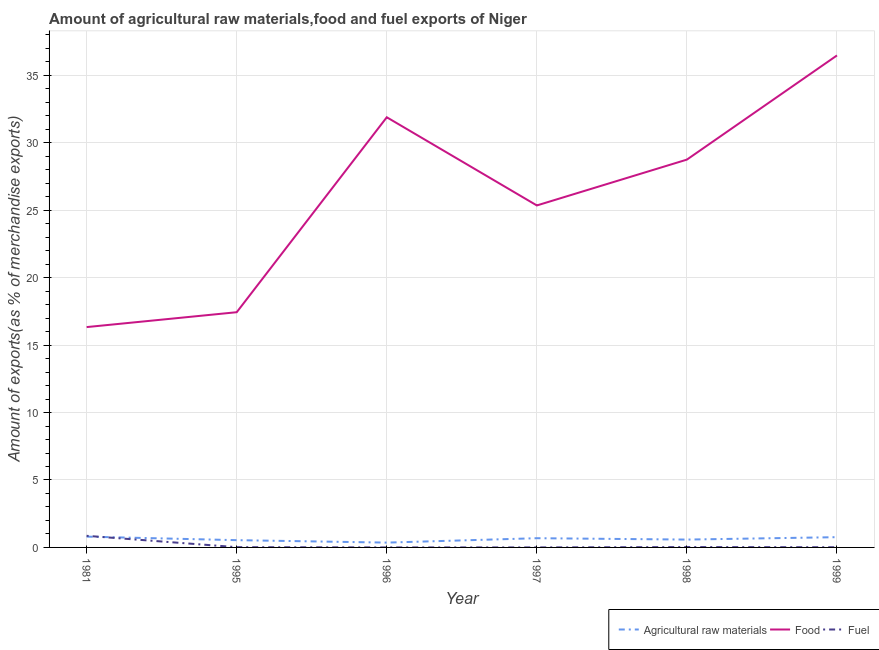How many different coloured lines are there?
Your answer should be compact. 3. What is the percentage of food exports in 1998?
Give a very brief answer. 28.76. Across all years, what is the maximum percentage of food exports?
Give a very brief answer. 36.48. Across all years, what is the minimum percentage of raw materials exports?
Offer a terse response. 0.36. In which year was the percentage of raw materials exports minimum?
Your answer should be very brief. 1996. What is the total percentage of food exports in the graph?
Your answer should be very brief. 156.27. What is the difference between the percentage of food exports in 1997 and that in 1999?
Provide a succinct answer. -11.12. What is the difference between the percentage of raw materials exports in 1981 and the percentage of fuel exports in 1997?
Provide a short and direct response. 0.8. What is the average percentage of fuel exports per year?
Provide a succinct answer. 0.15. In the year 1981, what is the difference between the percentage of fuel exports and percentage of food exports?
Provide a short and direct response. -15.48. In how many years, is the percentage of food exports greater than 22 %?
Make the answer very short. 4. What is the ratio of the percentage of fuel exports in 1995 to that in 1997?
Offer a terse response. 19.92. Is the difference between the percentage of food exports in 1997 and 1999 greater than the difference between the percentage of fuel exports in 1997 and 1999?
Provide a short and direct response. No. What is the difference between the highest and the second highest percentage of fuel exports?
Your answer should be compact. 0.83. What is the difference between the highest and the lowest percentage of fuel exports?
Provide a short and direct response. 0.86. Does the percentage of fuel exports monotonically increase over the years?
Keep it short and to the point. No. How many years are there in the graph?
Make the answer very short. 6. What is the difference between two consecutive major ticks on the Y-axis?
Give a very brief answer. 5. Are the values on the major ticks of Y-axis written in scientific E-notation?
Your answer should be very brief. No. Does the graph contain any zero values?
Ensure brevity in your answer.  No. How many legend labels are there?
Your answer should be compact. 3. What is the title of the graph?
Your response must be concise. Amount of agricultural raw materials,food and fuel exports of Niger. What is the label or title of the X-axis?
Provide a short and direct response. Year. What is the label or title of the Y-axis?
Provide a short and direct response. Amount of exports(as % of merchandise exports). What is the Amount of exports(as % of merchandise exports) in Agricultural raw materials in 1981?
Provide a short and direct response. 0.8. What is the Amount of exports(as % of merchandise exports) of Food in 1981?
Make the answer very short. 16.34. What is the Amount of exports(as % of merchandise exports) of Fuel in 1981?
Keep it short and to the point. 0.86. What is the Amount of exports(as % of merchandise exports) in Agricultural raw materials in 1995?
Ensure brevity in your answer.  0.54. What is the Amount of exports(as % of merchandise exports) of Food in 1995?
Provide a succinct answer. 17.44. What is the Amount of exports(as % of merchandise exports) in Fuel in 1995?
Your response must be concise. 0.02. What is the Amount of exports(as % of merchandise exports) of Agricultural raw materials in 1996?
Provide a succinct answer. 0.36. What is the Amount of exports(as % of merchandise exports) in Food in 1996?
Provide a short and direct response. 31.9. What is the Amount of exports(as % of merchandise exports) of Fuel in 1996?
Ensure brevity in your answer.  0. What is the Amount of exports(as % of merchandise exports) of Agricultural raw materials in 1997?
Make the answer very short. 0.68. What is the Amount of exports(as % of merchandise exports) in Food in 1997?
Your answer should be compact. 25.36. What is the Amount of exports(as % of merchandise exports) in Fuel in 1997?
Keep it short and to the point. 0. What is the Amount of exports(as % of merchandise exports) of Agricultural raw materials in 1998?
Make the answer very short. 0.58. What is the Amount of exports(as % of merchandise exports) in Food in 1998?
Offer a very short reply. 28.76. What is the Amount of exports(as % of merchandise exports) of Fuel in 1998?
Your response must be concise. 0.03. What is the Amount of exports(as % of merchandise exports) in Agricultural raw materials in 1999?
Offer a very short reply. 0.76. What is the Amount of exports(as % of merchandise exports) in Food in 1999?
Provide a short and direct response. 36.48. What is the Amount of exports(as % of merchandise exports) of Fuel in 1999?
Keep it short and to the point. 0.01. Across all years, what is the maximum Amount of exports(as % of merchandise exports) in Agricultural raw materials?
Make the answer very short. 0.8. Across all years, what is the maximum Amount of exports(as % of merchandise exports) of Food?
Your response must be concise. 36.48. Across all years, what is the maximum Amount of exports(as % of merchandise exports) of Fuel?
Provide a short and direct response. 0.86. Across all years, what is the minimum Amount of exports(as % of merchandise exports) in Agricultural raw materials?
Your answer should be very brief. 0.36. Across all years, what is the minimum Amount of exports(as % of merchandise exports) of Food?
Keep it short and to the point. 16.34. Across all years, what is the minimum Amount of exports(as % of merchandise exports) in Fuel?
Offer a terse response. 0. What is the total Amount of exports(as % of merchandise exports) in Agricultural raw materials in the graph?
Keep it short and to the point. 3.72. What is the total Amount of exports(as % of merchandise exports) in Food in the graph?
Ensure brevity in your answer.  156.27. What is the total Amount of exports(as % of merchandise exports) in Fuel in the graph?
Offer a terse response. 0.92. What is the difference between the Amount of exports(as % of merchandise exports) in Agricultural raw materials in 1981 and that in 1995?
Make the answer very short. 0.26. What is the difference between the Amount of exports(as % of merchandise exports) in Food in 1981 and that in 1995?
Your response must be concise. -1.1. What is the difference between the Amount of exports(as % of merchandise exports) of Fuel in 1981 and that in 1995?
Make the answer very short. 0.84. What is the difference between the Amount of exports(as % of merchandise exports) in Agricultural raw materials in 1981 and that in 1996?
Ensure brevity in your answer.  0.44. What is the difference between the Amount of exports(as % of merchandise exports) of Food in 1981 and that in 1996?
Provide a succinct answer. -15.56. What is the difference between the Amount of exports(as % of merchandise exports) of Fuel in 1981 and that in 1996?
Offer a terse response. 0.86. What is the difference between the Amount of exports(as % of merchandise exports) of Agricultural raw materials in 1981 and that in 1997?
Give a very brief answer. 0.12. What is the difference between the Amount of exports(as % of merchandise exports) in Food in 1981 and that in 1997?
Your answer should be very brief. -9.02. What is the difference between the Amount of exports(as % of merchandise exports) in Fuel in 1981 and that in 1997?
Offer a terse response. 0.86. What is the difference between the Amount of exports(as % of merchandise exports) of Agricultural raw materials in 1981 and that in 1998?
Make the answer very short. 0.22. What is the difference between the Amount of exports(as % of merchandise exports) of Food in 1981 and that in 1998?
Keep it short and to the point. -12.42. What is the difference between the Amount of exports(as % of merchandise exports) in Fuel in 1981 and that in 1998?
Ensure brevity in your answer.  0.83. What is the difference between the Amount of exports(as % of merchandise exports) in Agricultural raw materials in 1981 and that in 1999?
Ensure brevity in your answer.  0.04. What is the difference between the Amount of exports(as % of merchandise exports) of Food in 1981 and that in 1999?
Your answer should be very brief. -20.14. What is the difference between the Amount of exports(as % of merchandise exports) in Fuel in 1981 and that in 1999?
Make the answer very short. 0.85. What is the difference between the Amount of exports(as % of merchandise exports) of Agricultural raw materials in 1995 and that in 1996?
Provide a succinct answer. 0.18. What is the difference between the Amount of exports(as % of merchandise exports) in Food in 1995 and that in 1996?
Give a very brief answer. -14.46. What is the difference between the Amount of exports(as % of merchandise exports) of Fuel in 1995 and that in 1996?
Offer a terse response. 0.02. What is the difference between the Amount of exports(as % of merchandise exports) of Agricultural raw materials in 1995 and that in 1997?
Ensure brevity in your answer.  -0.14. What is the difference between the Amount of exports(as % of merchandise exports) in Food in 1995 and that in 1997?
Ensure brevity in your answer.  -7.92. What is the difference between the Amount of exports(as % of merchandise exports) of Fuel in 1995 and that in 1997?
Your response must be concise. 0.02. What is the difference between the Amount of exports(as % of merchandise exports) in Agricultural raw materials in 1995 and that in 1998?
Your response must be concise. -0.04. What is the difference between the Amount of exports(as % of merchandise exports) in Food in 1995 and that in 1998?
Your response must be concise. -11.32. What is the difference between the Amount of exports(as % of merchandise exports) of Fuel in 1995 and that in 1998?
Make the answer very short. -0.01. What is the difference between the Amount of exports(as % of merchandise exports) in Agricultural raw materials in 1995 and that in 1999?
Ensure brevity in your answer.  -0.22. What is the difference between the Amount of exports(as % of merchandise exports) in Food in 1995 and that in 1999?
Provide a short and direct response. -19.04. What is the difference between the Amount of exports(as % of merchandise exports) of Fuel in 1995 and that in 1999?
Provide a succinct answer. 0. What is the difference between the Amount of exports(as % of merchandise exports) in Agricultural raw materials in 1996 and that in 1997?
Make the answer very short. -0.33. What is the difference between the Amount of exports(as % of merchandise exports) of Food in 1996 and that in 1997?
Give a very brief answer. 6.54. What is the difference between the Amount of exports(as % of merchandise exports) of Fuel in 1996 and that in 1997?
Your answer should be very brief. -0. What is the difference between the Amount of exports(as % of merchandise exports) in Agricultural raw materials in 1996 and that in 1998?
Make the answer very short. -0.22. What is the difference between the Amount of exports(as % of merchandise exports) of Food in 1996 and that in 1998?
Offer a terse response. 3.14. What is the difference between the Amount of exports(as % of merchandise exports) of Fuel in 1996 and that in 1998?
Make the answer very short. -0.03. What is the difference between the Amount of exports(as % of merchandise exports) in Agricultural raw materials in 1996 and that in 1999?
Your response must be concise. -0.4. What is the difference between the Amount of exports(as % of merchandise exports) in Food in 1996 and that in 1999?
Keep it short and to the point. -4.59. What is the difference between the Amount of exports(as % of merchandise exports) of Fuel in 1996 and that in 1999?
Keep it short and to the point. -0.01. What is the difference between the Amount of exports(as % of merchandise exports) in Agricultural raw materials in 1997 and that in 1998?
Your answer should be compact. 0.1. What is the difference between the Amount of exports(as % of merchandise exports) in Food in 1997 and that in 1998?
Your response must be concise. -3.4. What is the difference between the Amount of exports(as % of merchandise exports) in Fuel in 1997 and that in 1998?
Give a very brief answer. -0.03. What is the difference between the Amount of exports(as % of merchandise exports) in Agricultural raw materials in 1997 and that in 1999?
Offer a terse response. -0.08. What is the difference between the Amount of exports(as % of merchandise exports) in Food in 1997 and that in 1999?
Make the answer very short. -11.12. What is the difference between the Amount of exports(as % of merchandise exports) of Fuel in 1997 and that in 1999?
Offer a very short reply. -0.01. What is the difference between the Amount of exports(as % of merchandise exports) in Agricultural raw materials in 1998 and that in 1999?
Make the answer very short. -0.18. What is the difference between the Amount of exports(as % of merchandise exports) in Food in 1998 and that in 1999?
Offer a very short reply. -7.72. What is the difference between the Amount of exports(as % of merchandise exports) of Fuel in 1998 and that in 1999?
Provide a succinct answer. 0.01. What is the difference between the Amount of exports(as % of merchandise exports) in Agricultural raw materials in 1981 and the Amount of exports(as % of merchandise exports) in Food in 1995?
Provide a short and direct response. -16.64. What is the difference between the Amount of exports(as % of merchandise exports) in Agricultural raw materials in 1981 and the Amount of exports(as % of merchandise exports) in Fuel in 1995?
Keep it short and to the point. 0.78. What is the difference between the Amount of exports(as % of merchandise exports) in Food in 1981 and the Amount of exports(as % of merchandise exports) in Fuel in 1995?
Give a very brief answer. 16.32. What is the difference between the Amount of exports(as % of merchandise exports) of Agricultural raw materials in 1981 and the Amount of exports(as % of merchandise exports) of Food in 1996?
Your response must be concise. -31.1. What is the difference between the Amount of exports(as % of merchandise exports) in Agricultural raw materials in 1981 and the Amount of exports(as % of merchandise exports) in Fuel in 1996?
Offer a terse response. 0.8. What is the difference between the Amount of exports(as % of merchandise exports) in Food in 1981 and the Amount of exports(as % of merchandise exports) in Fuel in 1996?
Provide a succinct answer. 16.34. What is the difference between the Amount of exports(as % of merchandise exports) of Agricultural raw materials in 1981 and the Amount of exports(as % of merchandise exports) of Food in 1997?
Your answer should be compact. -24.56. What is the difference between the Amount of exports(as % of merchandise exports) of Agricultural raw materials in 1981 and the Amount of exports(as % of merchandise exports) of Fuel in 1997?
Give a very brief answer. 0.8. What is the difference between the Amount of exports(as % of merchandise exports) in Food in 1981 and the Amount of exports(as % of merchandise exports) in Fuel in 1997?
Ensure brevity in your answer.  16.34. What is the difference between the Amount of exports(as % of merchandise exports) of Agricultural raw materials in 1981 and the Amount of exports(as % of merchandise exports) of Food in 1998?
Ensure brevity in your answer.  -27.96. What is the difference between the Amount of exports(as % of merchandise exports) of Agricultural raw materials in 1981 and the Amount of exports(as % of merchandise exports) of Fuel in 1998?
Offer a very short reply. 0.77. What is the difference between the Amount of exports(as % of merchandise exports) in Food in 1981 and the Amount of exports(as % of merchandise exports) in Fuel in 1998?
Your response must be concise. 16.31. What is the difference between the Amount of exports(as % of merchandise exports) of Agricultural raw materials in 1981 and the Amount of exports(as % of merchandise exports) of Food in 1999?
Your answer should be very brief. -35.68. What is the difference between the Amount of exports(as % of merchandise exports) of Agricultural raw materials in 1981 and the Amount of exports(as % of merchandise exports) of Fuel in 1999?
Make the answer very short. 0.79. What is the difference between the Amount of exports(as % of merchandise exports) in Food in 1981 and the Amount of exports(as % of merchandise exports) in Fuel in 1999?
Keep it short and to the point. 16.32. What is the difference between the Amount of exports(as % of merchandise exports) in Agricultural raw materials in 1995 and the Amount of exports(as % of merchandise exports) in Food in 1996?
Provide a short and direct response. -31.36. What is the difference between the Amount of exports(as % of merchandise exports) of Agricultural raw materials in 1995 and the Amount of exports(as % of merchandise exports) of Fuel in 1996?
Provide a succinct answer. 0.54. What is the difference between the Amount of exports(as % of merchandise exports) of Food in 1995 and the Amount of exports(as % of merchandise exports) of Fuel in 1996?
Give a very brief answer. 17.44. What is the difference between the Amount of exports(as % of merchandise exports) in Agricultural raw materials in 1995 and the Amount of exports(as % of merchandise exports) in Food in 1997?
Your answer should be very brief. -24.82. What is the difference between the Amount of exports(as % of merchandise exports) of Agricultural raw materials in 1995 and the Amount of exports(as % of merchandise exports) of Fuel in 1997?
Offer a very short reply. 0.54. What is the difference between the Amount of exports(as % of merchandise exports) in Food in 1995 and the Amount of exports(as % of merchandise exports) in Fuel in 1997?
Make the answer very short. 17.44. What is the difference between the Amount of exports(as % of merchandise exports) of Agricultural raw materials in 1995 and the Amount of exports(as % of merchandise exports) of Food in 1998?
Offer a terse response. -28.22. What is the difference between the Amount of exports(as % of merchandise exports) of Agricultural raw materials in 1995 and the Amount of exports(as % of merchandise exports) of Fuel in 1998?
Give a very brief answer. 0.51. What is the difference between the Amount of exports(as % of merchandise exports) of Food in 1995 and the Amount of exports(as % of merchandise exports) of Fuel in 1998?
Offer a terse response. 17.41. What is the difference between the Amount of exports(as % of merchandise exports) of Agricultural raw materials in 1995 and the Amount of exports(as % of merchandise exports) of Food in 1999?
Your answer should be compact. -35.94. What is the difference between the Amount of exports(as % of merchandise exports) of Agricultural raw materials in 1995 and the Amount of exports(as % of merchandise exports) of Fuel in 1999?
Give a very brief answer. 0.52. What is the difference between the Amount of exports(as % of merchandise exports) in Food in 1995 and the Amount of exports(as % of merchandise exports) in Fuel in 1999?
Make the answer very short. 17.43. What is the difference between the Amount of exports(as % of merchandise exports) in Agricultural raw materials in 1996 and the Amount of exports(as % of merchandise exports) in Food in 1997?
Make the answer very short. -25. What is the difference between the Amount of exports(as % of merchandise exports) in Agricultural raw materials in 1996 and the Amount of exports(as % of merchandise exports) in Fuel in 1997?
Ensure brevity in your answer.  0.36. What is the difference between the Amount of exports(as % of merchandise exports) of Food in 1996 and the Amount of exports(as % of merchandise exports) of Fuel in 1997?
Your answer should be very brief. 31.89. What is the difference between the Amount of exports(as % of merchandise exports) of Agricultural raw materials in 1996 and the Amount of exports(as % of merchandise exports) of Food in 1998?
Make the answer very short. -28.4. What is the difference between the Amount of exports(as % of merchandise exports) of Agricultural raw materials in 1996 and the Amount of exports(as % of merchandise exports) of Fuel in 1998?
Your response must be concise. 0.33. What is the difference between the Amount of exports(as % of merchandise exports) in Food in 1996 and the Amount of exports(as % of merchandise exports) in Fuel in 1998?
Provide a succinct answer. 31.87. What is the difference between the Amount of exports(as % of merchandise exports) in Agricultural raw materials in 1996 and the Amount of exports(as % of merchandise exports) in Food in 1999?
Offer a terse response. -36.12. What is the difference between the Amount of exports(as % of merchandise exports) in Agricultural raw materials in 1996 and the Amount of exports(as % of merchandise exports) in Fuel in 1999?
Offer a very short reply. 0.34. What is the difference between the Amount of exports(as % of merchandise exports) of Food in 1996 and the Amount of exports(as % of merchandise exports) of Fuel in 1999?
Make the answer very short. 31.88. What is the difference between the Amount of exports(as % of merchandise exports) in Agricultural raw materials in 1997 and the Amount of exports(as % of merchandise exports) in Food in 1998?
Provide a succinct answer. -28.07. What is the difference between the Amount of exports(as % of merchandise exports) in Agricultural raw materials in 1997 and the Amount of exports(as % of merchandise exports) in Fuel in 1998?
Provide a short and direct response. 0.66. What is the difference between the Amount of exports(as % of merchandise exports) of Food in 1997 and the Amount of exports(as % of merchandise exports) of Fuel in 1998?
Keep it short and to the point. 25.33. What is the difference between the Amount of exports(as % of merchandise exports) in Agricultural raw materials in 1997 and the Amount of exports(as % of merchandise exports) in Food in 1999?
Give a very brief answer. -35.8. What is the difference between the Amount of exports(as % of merchandise exports) of Agricultural raw materials in 1997 and the Amount of exports(as % of merchandise exports) of Fuel in 1999?
Offer a very short reply. 0.67. What is the difference between the Amount of exports(as % of merchandise exports) of Food in 1997 and the Amount of exports(as % of merchandise exports) of Fuel in 1999?
Offer a terse response. 25.34. What is the difference between the Amount of exports(as % of merchandise exports) of Agricultural raw materials in 1998 and the Amount of exports(as % of merchandise exports) of Food in 1999?
Provide a succinct answer. -35.9. What is the difference between the Amount of exports(as % of merchandise exports) in Agricultural raw materials in 1998 and the Amount of exports(as % of merchandise exports) in Fuel in 1999?
Keep it short and to the point. 0.57. What is the difference between the Amount of exports(as % of merchandise exports) in Food in 1998 and the Amount of exports(as % of merchandise exports) in Fuel in 1999?
Provide a short and direct response. 28.74. What is the average Amount of exports(as % of merchandise exports) in Agricultural raw materials per year?
Offer a terse response. 0.62. What is the average Amount of exports(as % of merchandise exports) of Food per year?
Your answer should be compact. 26.05. What is the average Amount of exports(as % of merchandise exports) in Fuel per year?
Your answer should be compact. 0.15. In the year 1981, what is the difference between the Amount of exports(as % of merchandise exports) of Agricultural raw materials and Amount of exports(as % of merchandise exports) of Food?
Ensure brevity in your answer.  -15.54. In the year 1981, what is the difference between the Amount of exports(as % of merchandise exports) of Agricultural raw materials and Amount of exports(as % of merchandise exports) of Fuel?
Offer a very short reply. -0.06. In the year 1981, what is the difference between the Amount of exports(as % of merchandise exports) of Food and Amount of exports(as % of merchandise exports) of Fuel?
Offer a very short reply. 15.48. In the year 1995, what is the difference between the Amount of exports(as % of merchandise exports) of Agricultural raw materials and Amount of exports(as % of merchandise exports) of Food?
Your answer should be compact. -16.9. In the year 1995, what is the difference between the Amount of exports(as % of merchandise exports) in Agricultural raw materials and Amount of exports(as % of merchandise exports) in Fuel?
Your answer should be compact. 0.52. In the year 1995, what is the difference between the Amount of exports(as % of merchandise exports) of Food and Amount of exports(as % of merchandise exports) of Fuel?
Offer a very short reply. 17.42. In the year 1996, what is the difference between the Amount of exports(as % of merchandise exports) in Agricultural raw materials and Amount of exports(as % of merchandise exports) in Food?
Offer a terse response. -31.54. In the year 1996, what is the difference between the Amount of exports(as % of merchandise exports) of Agricultural raw materials and Amount of exports(as % of merchandise exports) of Fuel?
Provide a succinct answer. 0.36. In the year 1996, what is the difference between the Amount of exports(as % of merchandise exports) of Food and Amount of exports(as % of merchandise exports) of Fuel?
Offer a very short reply. 31.9. In the year 1997, what is the difference between the Amount of exports(as % of merchandise exports) in Agricultural raw materials and Amount of exports(as % of merchandise exports) in Food?
Your answer should be very brief. -24.67. In the year 1997, what is the difference between the Amount of exports(as % of merchandise exports) in Agricultural raw materials and Amount of exports(as % of merchandise exports) in Fuel?
Make the answer very short. 0.68. In the year 1997, what is the difference between the Amount of exports(as % of merchandise exports) of Food and Amount of exports(as % of merchandise exports) of Fuel?
Your answer should be very brief. 25.36. In the year 1998, what is the difference between the Amount of exports(as % of merchandise exports) of Agricultural raw materials and Amount of exports(as % of merchandise exports) of Food?
Provide a succinct answer. -28.17. In the year 1998, what is the difference between the Amount of exports(as % of merchandise exports) of Agricultural raw materials and Amount of exports(as % of merchandise exports) of Fuel?
Your answer should be compact. 0.56. In the year 1998, what is the difference between the Amount of exports(as % of merchandise exports) in Food and Amount of exports(as % of merchandise exports) in Fuel?
Make the answer very short. 28.73. In the year 1999, what is the difference between the Amount of exports(as % of merchandise exports) in Agricultural raw materials and Amount of exports(as % of merchandise exports) in Food?
Ensure brevity in your answer.  -35.72. In the year 1999, what is the difference between the Amount of exports(as % of merchandise exports) of Agricultural raw materials and Amount of exports(as % of merchandise exports) of Fuel?
Provide a succinct answer. 0.75. In the year 1999, what is the difference between the Amount of exports(as % of merchandise exports) of Food and Amount of exports(as % of merchandise exports) of Fuel?
Your answer should be very brief. 36.47. What is the ratio of the Amount of exports(as % of merchandise exports) of Agricultural raw materials in 1981 to that in 1995?
Provide a short and direct response. 1.48. What is the ratio of the Amount of exports(as % of merchandise exports) of Food in 1981 to that in 1995?
Provide a short and direct response. 0.94. What is the ratio of the Amount of exports(as % of merchandise exports) in Fuel in 1981 to that in 1995?
Provide a succinct answer. 44.45. What is the ratio of the Amount of exports(as % of merchandise exports) in Agricultural raw materials in 1981 to that in 1996?
Give a very brief answer. 2.24. What is the ratio of the Amount of exports(as % of merchandise exports) in Food in 1981 to that in 1996?
Your response must be concise. 0.51. What is the ratio of the Amount of exports(as % of merchandise exports) of Fuel in 1981 to that in 1996?
Your response must be concise. 5528.42. What is the ratio of the Amount of exports(as % of merchandise exports) of Agricultural raw materials in 1981 to that in 1997?
Offer a very short reply. 1.17. What is the ratio of the Amount of exports(as % of merchandise exports) of Food in 1981 to that in 1997?
Make the answer very short. 0.64. What is the ratio of the Amount of exports(as % of merchandise exports) of Fuel in 1981 to that in 1997?
Ensure brevity in your answer.  885.19. What is the ratio of the Amount of exports(as % of merchandise exports) of Agricultural raw materials in 1981 to that in 1998?
Make the answer very short. 1.38. What is the ratio of the Amount of exports(as % of merchandise exports) of Food in 1981 to that in 1998?
Your response must be concise. 0.57. What is the ratio of the Amount of exports(as % of merchandise exports) of Fuel in 1981 to that in 1998?
Provide a succinct answer. 32.17. What is the ratio of the Amount of exports(as % of merchandise exports) in Agricultural raw materials in 1981 to that in 1999?
Offer a terse response. 1.05. What is the ratio of the Amount of exports(as % of merchandise exports) of Food in 1981 to that in 1999?
Offer a terse response. 0.45. What is the ratio of the Amount of exports(as % of merchandise exports) of Fuel in 1981 to that in 1999?
Keep it short and to the point. 59.36. What is the ratio of the Amount of exports(as % of merchandise exports) of Agricultural raw materials in 1995 to that in 1996?
Provide a short and direct response. 1.51. What is the ratio of the Amount of exports(as % of merchandise exports) in Food in 1995 to that in 1996?
Make the answer very short. 0.55. What is the ratio of the Amount of exports(as % of merchandise exports) of Fuel in 1995 to that in 1996?
Provide a short and direct response. 124.39. What is the ratio of the Amount of exports(as % of merchandise exports) of Agricultural raw materials in 1995 to that in 1997?
Offer a very short reply. 0.79. What is the ratio of the Amount of exports(as % of merchandise exports) in Food in 1995 to that in 1997?
Keep it short and to the point. 0.69. What is the ratio of the Amount of exports(as % of merchandise exports) of Fuel in 1995 to that in 1997?
Provide a succinct answer. 19.92. What is the ratio of the Amount of exports(as % of merchandise exports) in Agricultural raw materials in 1995 to that in 1998?
Your response must be concise. 0.93. What is the ratio of the Amount of exports(as % of merchandise exports) in Food in 1995 to that in 1998?
Give a very brief answer. 0.61. What is the ratio of the Amount of exports(as % of merchandise exports) in Fuel in 1995 to that in 1998?
Your answer should be very brief. 0.72. What is the ratio of the Amount of exports(as % of merchandise exports) of Agricultural raw materials in 1995 to that in 1999?
Provide a succinct answer. 0.71. What is the ratio of the Amount of exports(as % of merchandise exports) in Food in 1995 to that in 1999?
Provide a succinct answer. 0.48. What is the ratio of the Amount of exports(as % of merchandise exports) in Fuel in 1995 to that in 1999?
Offer a very short reply. 1.34. What is the ratio of the Amount of exports(as % of merchandise exports) of Agricultural raw materials in 1996 to that in 1997?
Provide a short and direct response. 0.52. What is the ratio of the Amount of exports(as % of merchandise exports) in Food in 1996 to that in 1997?
Offer a very short reply. 1.26. What is the ratio of the Amount of exports(as % of merchandise exports) of Fuel in 1996 to that in 1997?
Ensure brevity in your answer.  0.16. What is the ratio of the Amount of exports(as % of merchandise exports) in Agricultural raw materials in 1996 to that in 1998?
Offer a terse response. 0.61. What is the ratio of the Amount of exports(as % of merchandise exports) of Food in 1996 to that in 1998?
Provide a short and direct response. 1.11. What is the ratio of the Amount of exports(as % of merchandise exports) of Fuel in 1996 to that in 1998?
Give a very brief answer. 0.01. What is the ratio of the Amount of exports(as % of merchandise exports) in Agricultural raw materials in 1996 to that in 1999?
Your answer should be compact. 0.47. What is the ratio of the Amount of exports(as % of merchandise exports) in Food in 1996 to that in 1999?
Keep it short and to the point. 0.87. What is the ratio of the Amount of exports(as % of merchandise exports) in Fuel in 1996 to that in 1999?
Ensure brevity in your answer.  0.01. What is the ratio of the Amount of exports(as % of merchandise exports) in Agricultural raw materials in 1997 to that in 1998?
Provide a succinct answer. 1.18. What is the ratio of the Amount of exports(as % of merchandise exports) in Food in 1997 to that in 1998?
Make the answer very short. 0.88. What is the ratio of the Amount of exports(as % of merchandise exports) of Fuel in 1997 to that in 1998?
Your answer should be compact. 0.04. What is the ratio of the Amount of exports(as % of merchandise exports) of Agricultural raw materials in 1997 to that in 1999?
Provide a short and direct response. 0.9. What is the ratio of the Amount of exports(as % of merchandise exports) in Food in 1997 to that in 1999?
Your answer should be very brief. 0.7. What is the ratio of the Amount of exports(as % of merchandise exports) in Fuel in 1997 to that in 1999?
Your answer should be compact. 0.07. What is the ratio of the Amount of exports(as % of merchandise exports) in Agricultural raw materials in 1998 to that in 1999?
Your response must be concise. 0.77. What is the ratio of the Amount of exports(as % of merchandise exports) in Food in 1998 to that in 1999?
Ensure brevity in your answer.  0.79. What is the ratio of the Amount of exports(as % of merchandise exports) in Fuel in 1998 to that in 1999?
Make the answer very short. 1.85. What is the difference between the highest and the second highest Amount of exports(as % of merchandise exports) of Agricultural raw materials?
Provide a short and direct response. 0.04. What is the difference between the highest and the second highest Amount of exports(as % of merchandise exports) of Food?
Provide a succinct answer. 4.59. What is the difference between the highest and the second highest Amount of exports(as % of merchandise exports) in Fuel?
Ensure brevity in your answer.  0.83. What is the difference between the highest and the lowest Amount of exports(as % of merchandise exports) in Agricultural raw materials?
Your answer should be very brief. 0.44. What is the difference between the highest and the lowest Amount of exports(as % of merchandise exports) of Food?
Provide a short and direct response. 20.14. What is the difference between the highest and the lowest Amount of exports(as % of merchandise exports) of Fuel?
Your answer should be very brief. 0.86. 